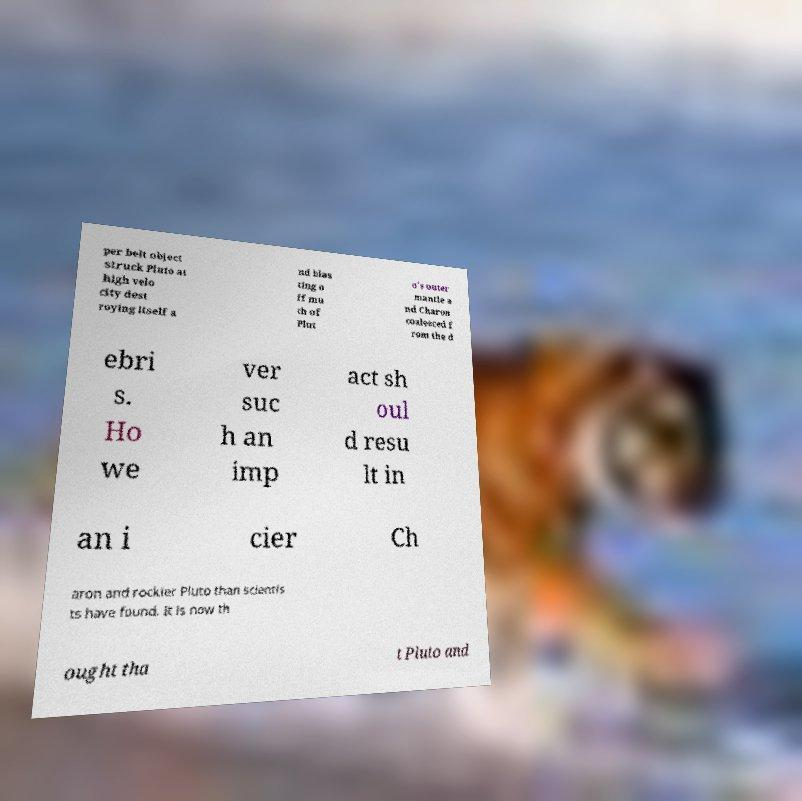What messages or text are displayed in this image? I need them in a readable, typed format. per belt object struck Pluto at high velo city dest roying itself a nd blas ting o ff mu ch of Plut o's outer mantle a nd Charon coalesced f rom the d ebri s. Ho we ver suc h an imp act sh oul d resu lt in an i cier Ch aron and rockier Pluto than scientis ts have found. It is now th ought tha t Pluto and 